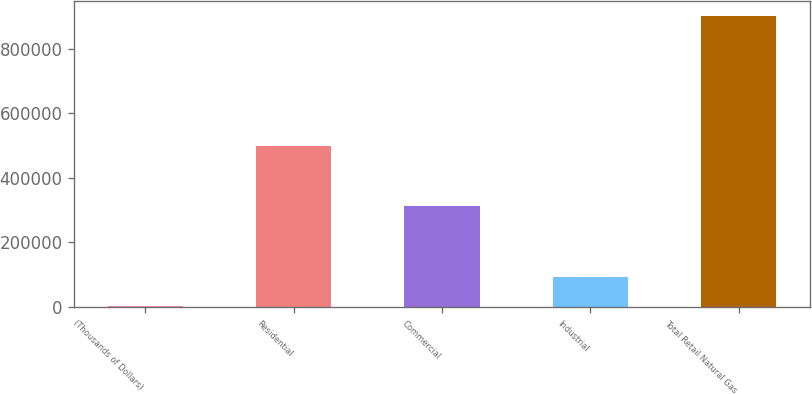Convert chart. <chart><loc_0><loc_0><loc_500><loc_500><bar_chart><fcel>(Thousands of Dollars)<fcel>Residential<fcel>Commercial<fcel>Industrial<fcel>Total Retail Natural Gas<nl><fcel>2017<fcel>500229<fcel>312034<fcel>92044<fcel>902287<nl></chart> 